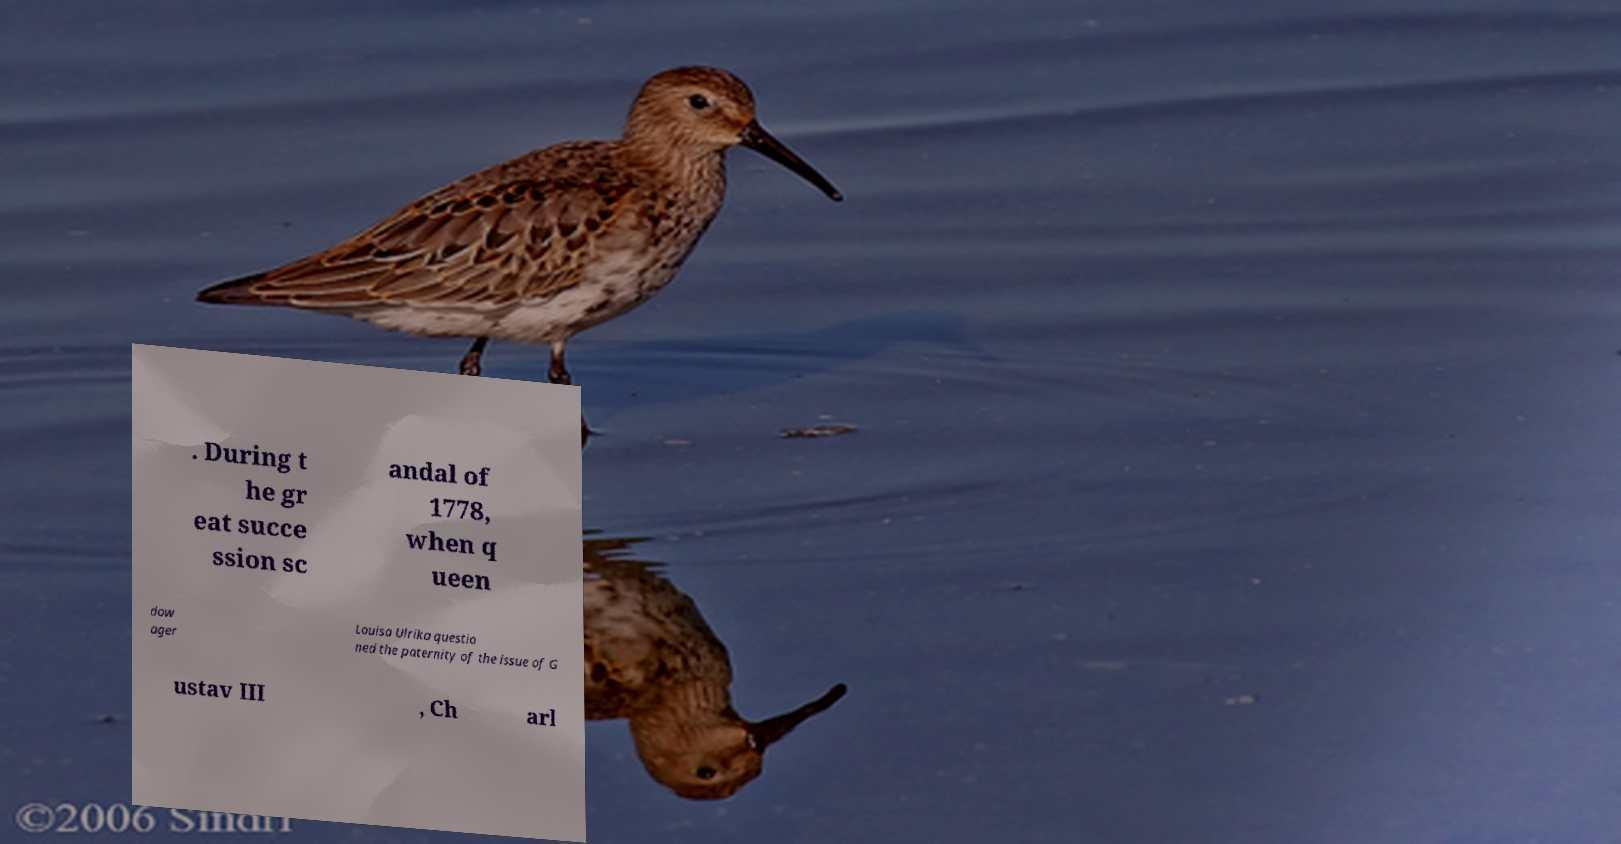There's text embedded in this image that I need extracted. Can you transcribe it verbatim? . During t he gr eat succe ssion sc andal of 1778, when q ueen dow ager Louisa Ulrika questio ned the paternity of the issue of G ustav III , Ch arl 